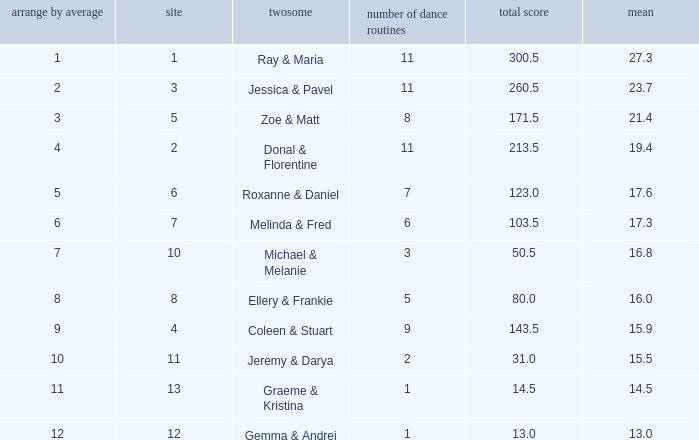If your rank by average is 9, what is the name of the couple? Coleen & Stuart. 